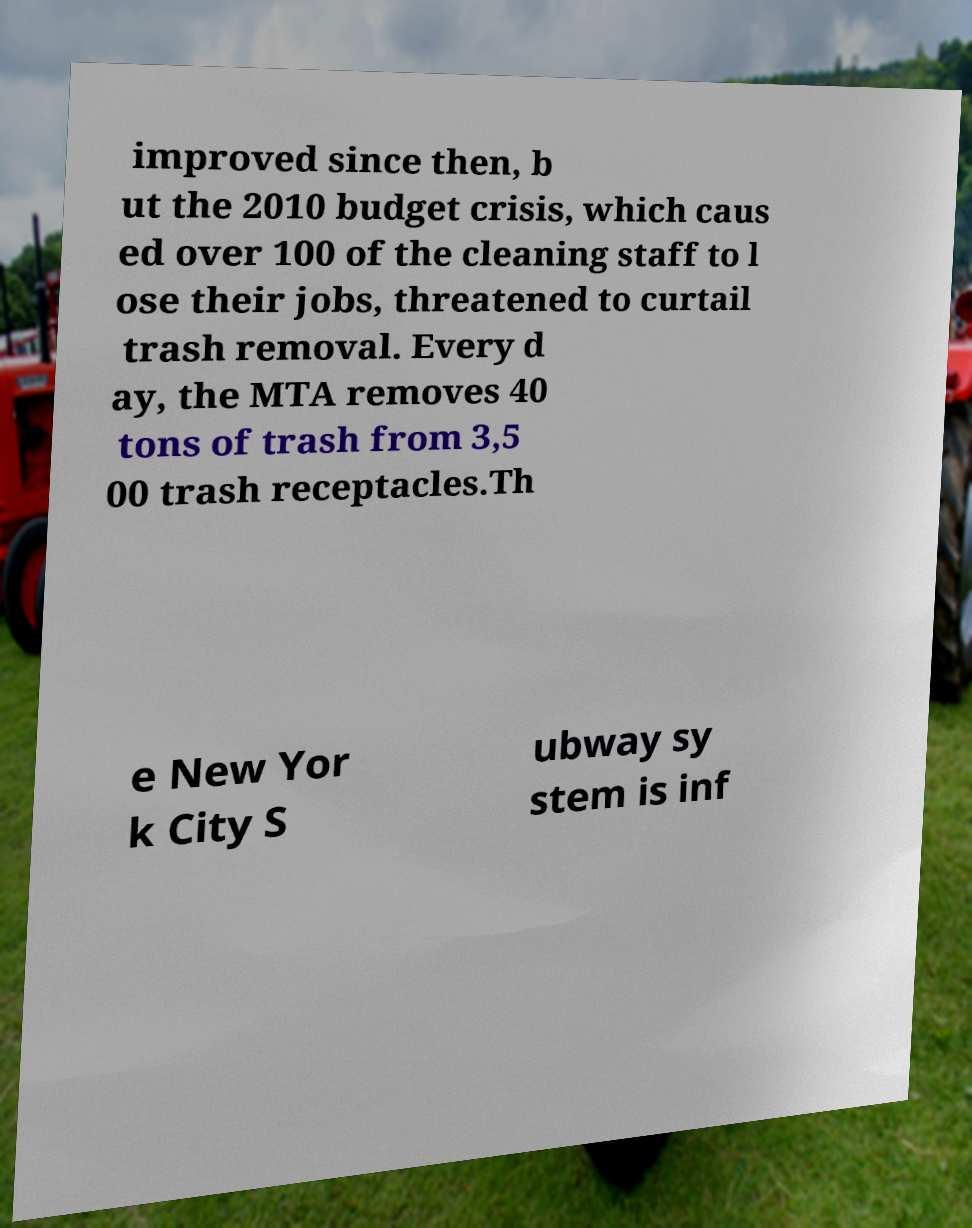I need the written content from this picture converted into text. Can you do that? improved since then, b ut the 2010 budget crisis, which caus ed over 100 of the cleaning staff to l ose their jobs, threatened to curtail trash removal. Every d ay, the MTA removes 40 tons of trash from 3,5 00 trash receptacles.Th e New Yor k City S ubway sy stem is inf 